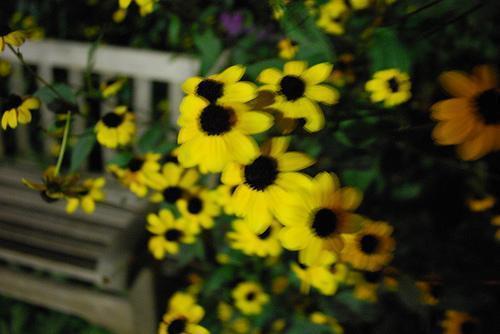How many benches are there?
Give a very brief answer. 1. 